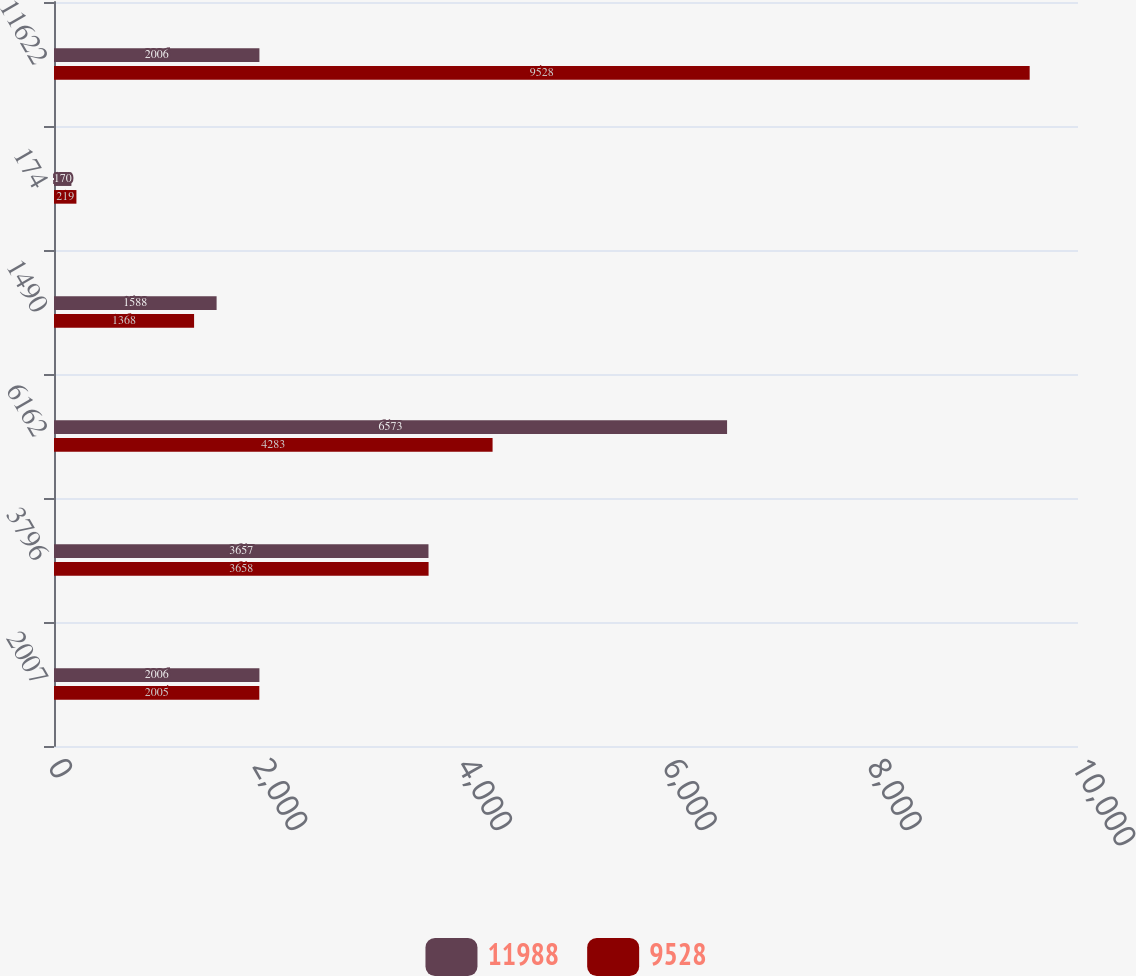<chart> <loc_0><loc_0><loc_500><loc_500><stacked_bar_chart><ecel><fcel>2007<fcel>3796<fcel>6162<fcel>1490<fcel>174<fcel>11622<nl><fcel>11988<fcel>2006<fcel>3657<fcel>6573<fcel>1588<fcel>170<fcel>2006<nl><fcel>9528<fcel>2005<fcel>3658<fcel>4283<fcel>1368<fcel>219<fcel>9528<nl></chart> 